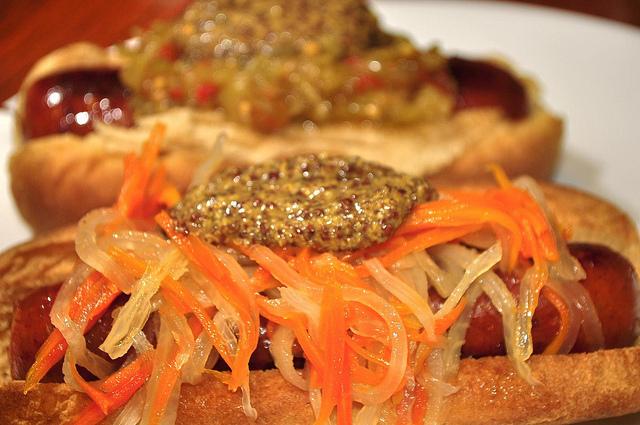Is there cheese?
Be succinct. Yes. Is this healthy?
Give a very brief answer. No. What type of meat is this?
Be succinct. Hot dog. 